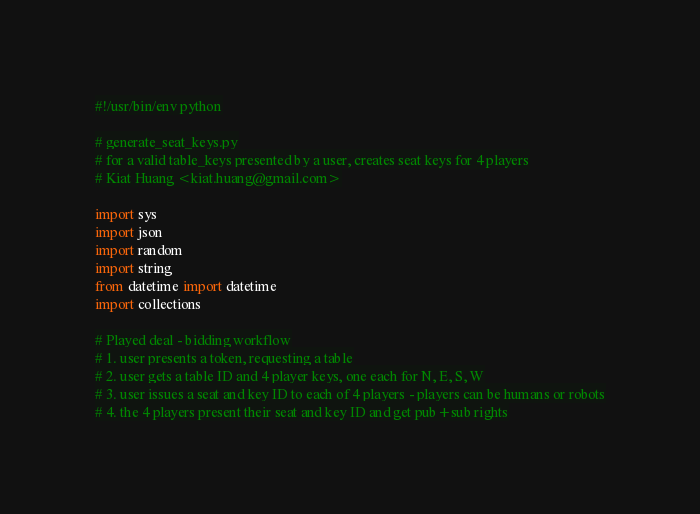Convert code to text. <code><loc_0><loc_0><loc_500><loc_500><_Python_>#!/usr/bin/env python

# generate_seat_keys.py
# for a valid table_keys presented by a user, creates seat keys for 4 players
# Kiat Huang <kiat.huang@gmail.com>

import sys
import json
import random
import string
from datetime import datetime
import collections

# Played deal - bidding workflow
# 1. user presents a token, requesting a table
# 2. user gets a table ID and 4 player keys, one each for N, E, S, W
# 3. user issues a seat and key ID to each of 4 players - players can be humans or robots
# 4. the 4 players present their seat and key ID and get pub+sub rights</code> 